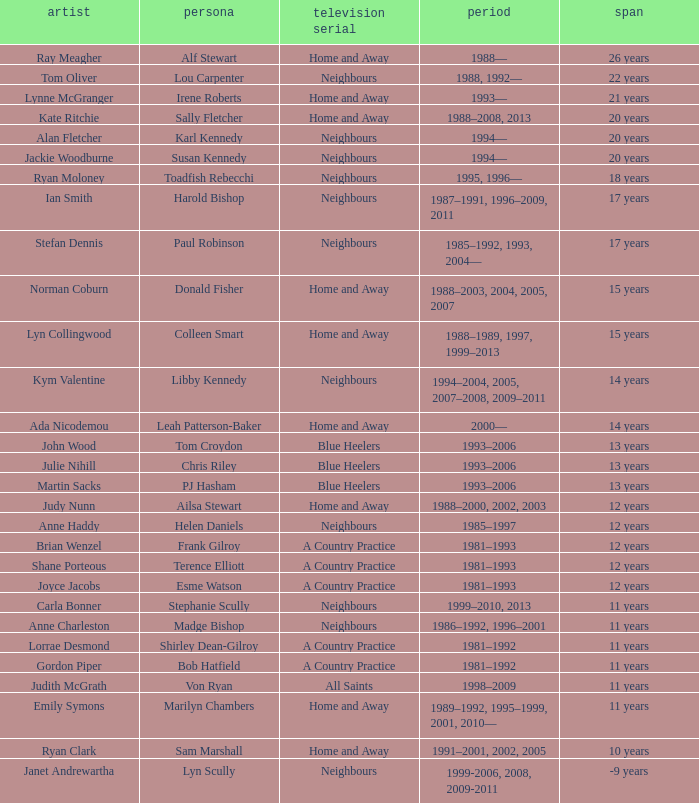Which years did Martin Sacks work on a soap opera? 1993–2006. 